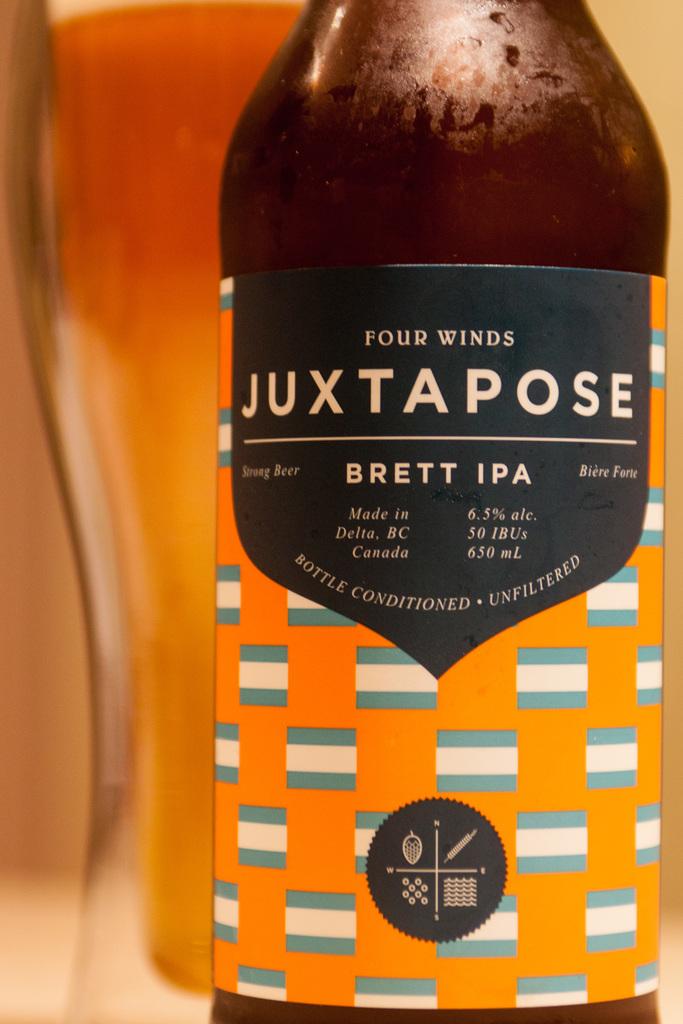What kind of beer is this?
Give a very brief answer. Brett ipa. What is the brand?
Your answer should be compact. Four winds. 